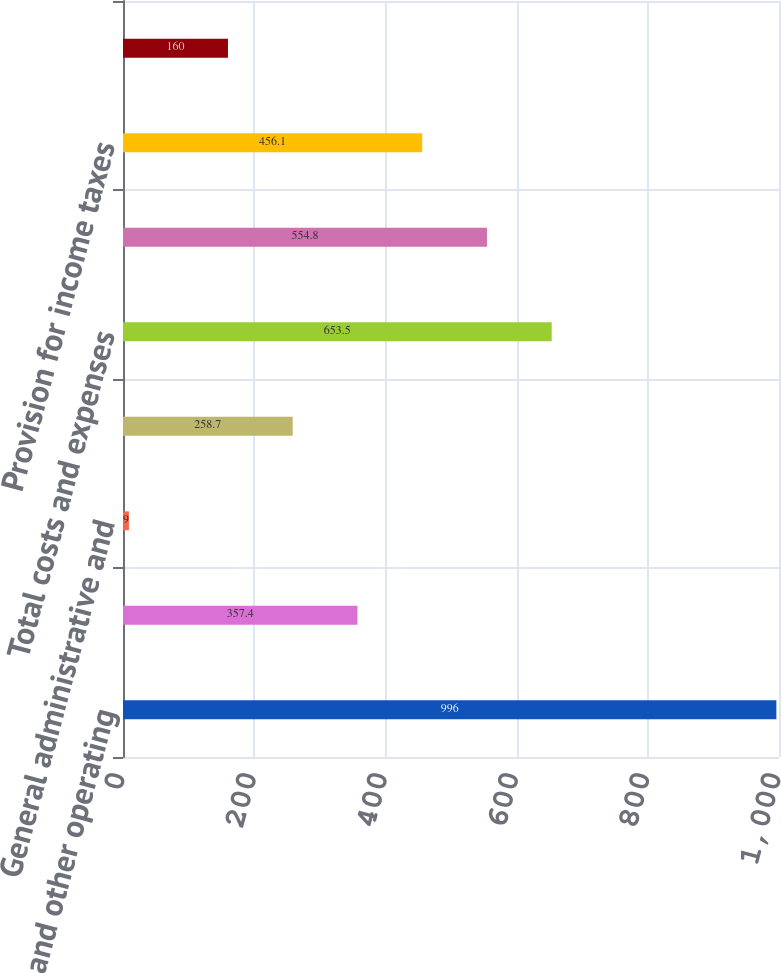Convert chart to OTSL. <chart><loc_0><loc_0><loc_500><loc_500><bar_chart><fcel>Sales and other operating<fcel>Production expenses including<fcel>General administrative and<fcel>Depreciation depletion and<fcel>Total costs and expenses<fcel>Results of operations before<fcel>Provision for income taxes<fcel>Results of operations<nl><fcel>996<fcel>357.4<fcel>9<fcel>258.7<fcel>653.5<fcel>554.8<fcel>456.1<fcel>160<nl></chart> 